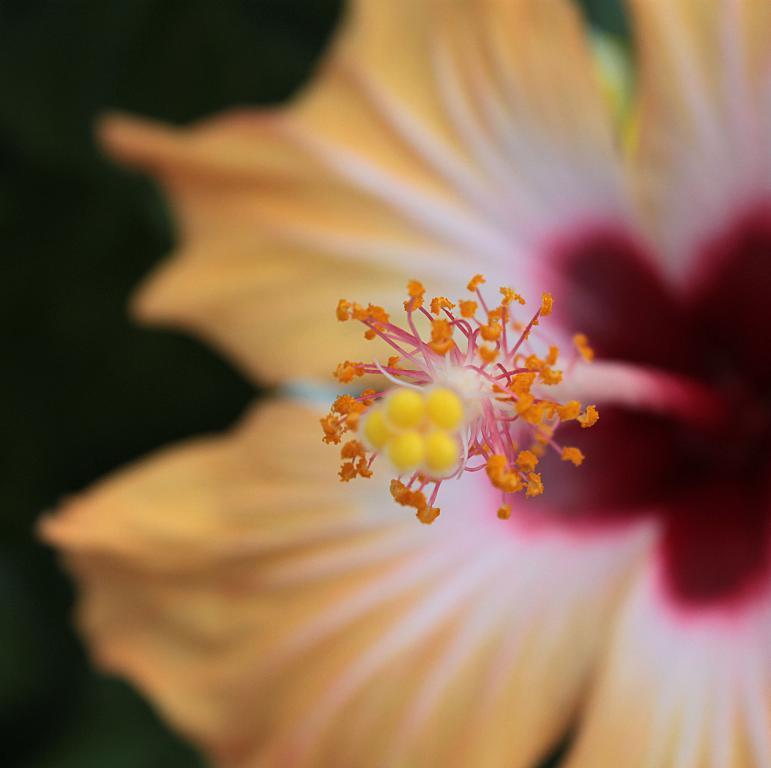Can you describe this image briefly? In this image, we can see a flower which is in yellow and red color. In the background, we can see black color. 